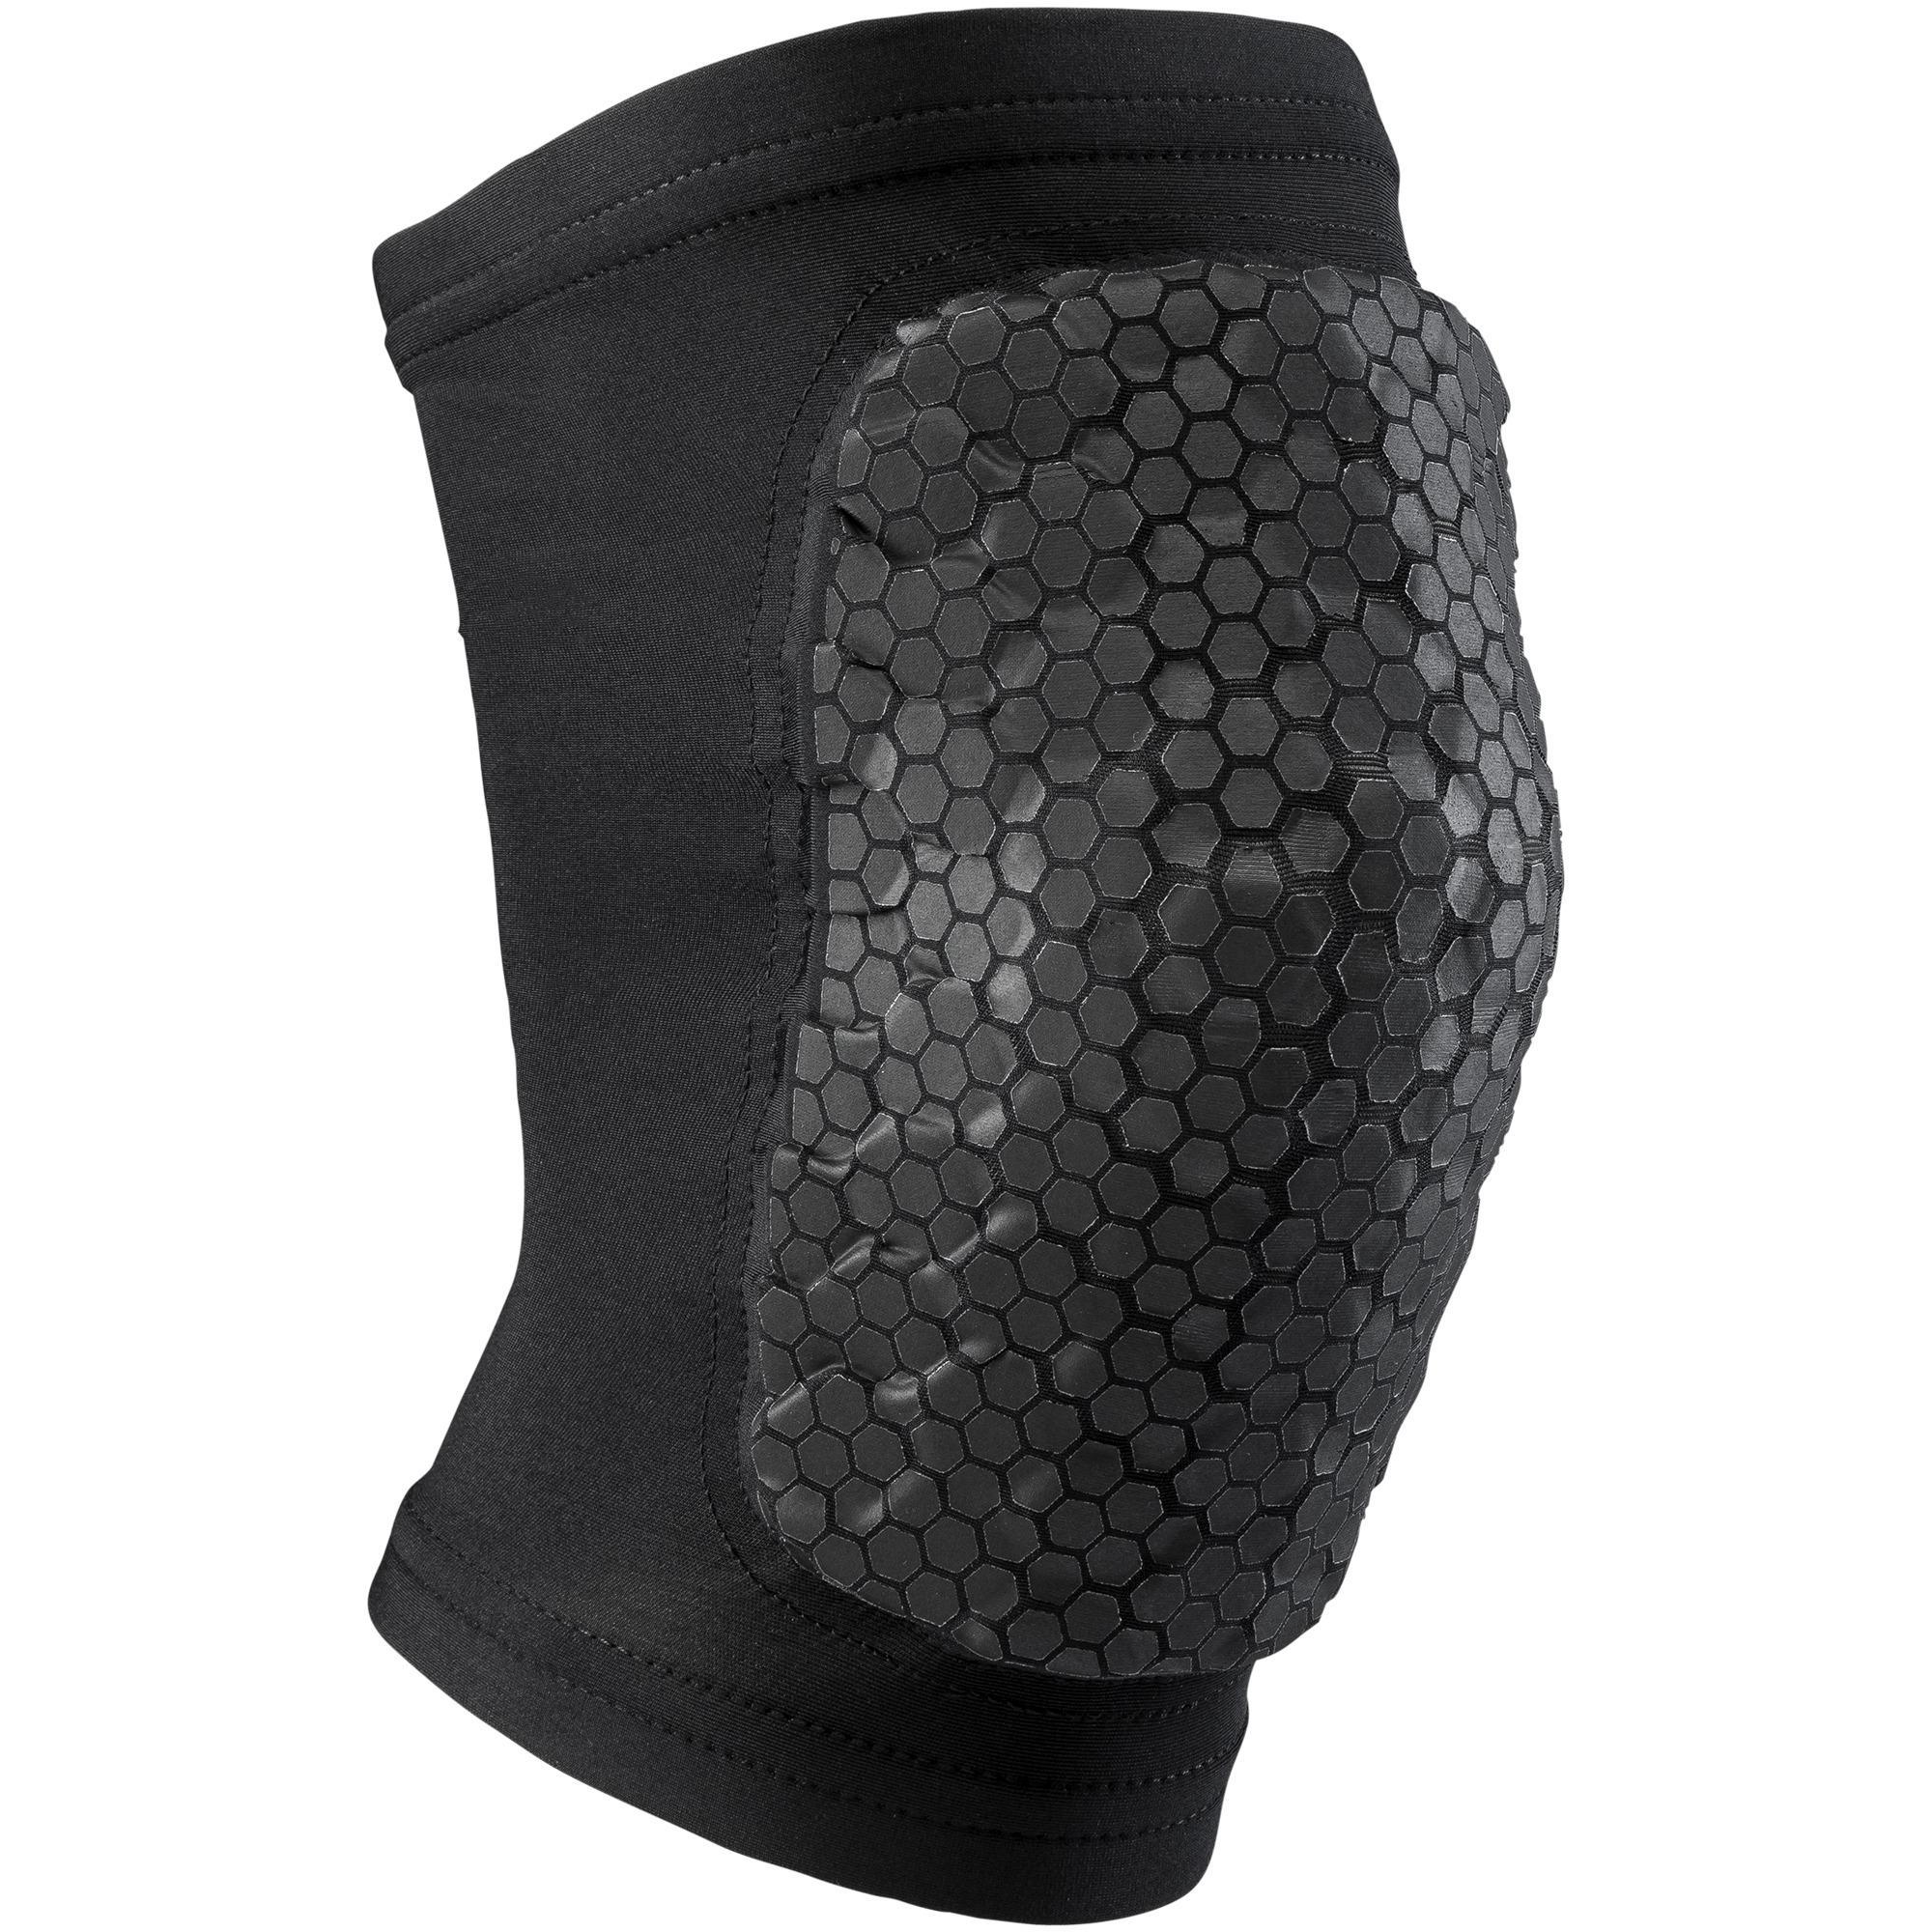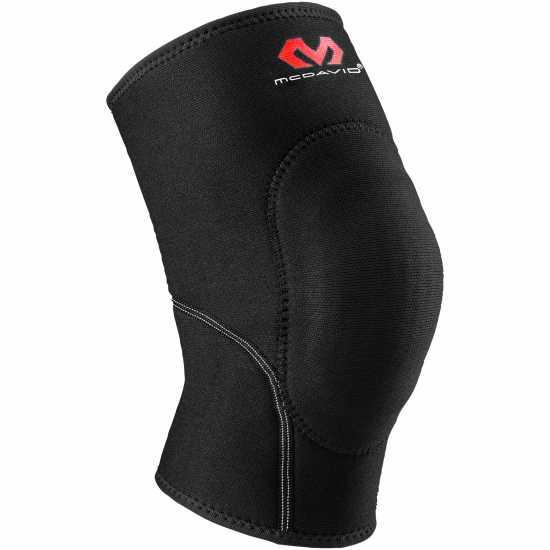The first image is the image on the left, the second image is the image on the right. Analyze the images presented: Is the assertion "Left image features one right-facing kneepad." valid? Answer yes or no. Yes. 